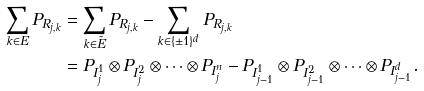<formula> <loc_0><loc_0><loc_500><loc_500>\sum _ { k \in { E } } P _ { R _ { j , k } } & = \sum _ { k \in \tilde { E } } P _ { R _ { j , k } } - \sum _ { k \in \{ \pm 1 \} ^ { d } } P _ { R _ { j , k } } \\ & = P _ { I _ { j } ^ { 1 } } \otimes P _ { I _ { j } ^ { 2 } } \otimes \cdots \otimes P _ { I _ { j } ^ { n } } - P _ { I _ { j - 1 } ^ { 1 } } \otimes P _ { I _ { j - 1 } ^ { 2 } } \otimes \cdots \otimes P _ { I _ { j - 1 } ^ { d } } .</formula> 